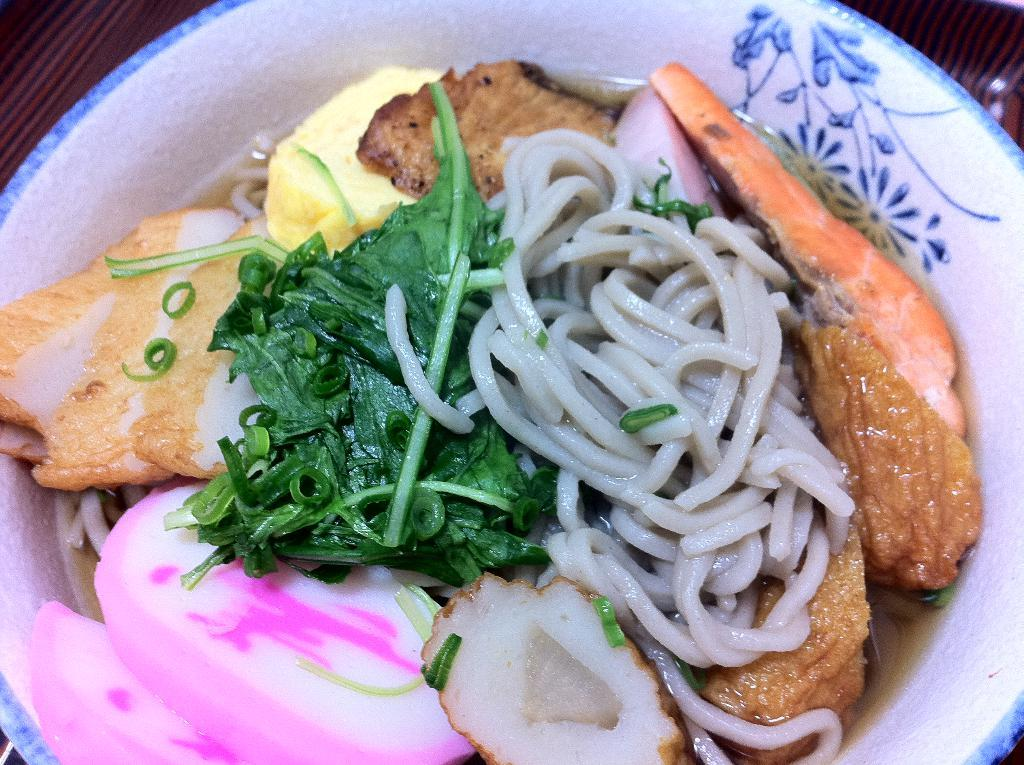What objects are present in the image related to food preparation or serving? There are dishes and a bowl with vegetables in the image. Where is the bowl with vegetables located? The bowl with vegetables is placed on a table in the image. What type of ear is visible in the image? There is no ear present in the image. Is there a church depicted in the image? No, there is no church depicted in the image. 